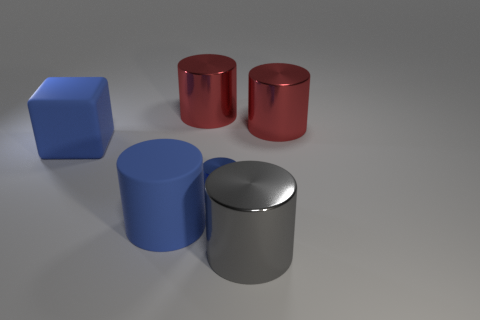Subtract all shiny cylinders. How many cylinders are left? 1 Add 4 brown metallic cylinders. How many objects exist? 10 Subtract all gray cylinders. How many cylinders are left? 4 Subtract all cylinders. How many objects are left? 1 Subtract all brown blocks. How many red cylinders are left? 2 Subtract 1 blocks. How many blocks are left? 0 Add 4 green cylinders. How many green cylinders exist? 4 Subtract 0 red spheres. How many objects are left? 6 Subtract all gray cylinders. Subtract all gray balls. How many cylinders are left? 4 Subtract all big matte cubes. Subtract all blue rubber cylinders. How many objects are left? 4 